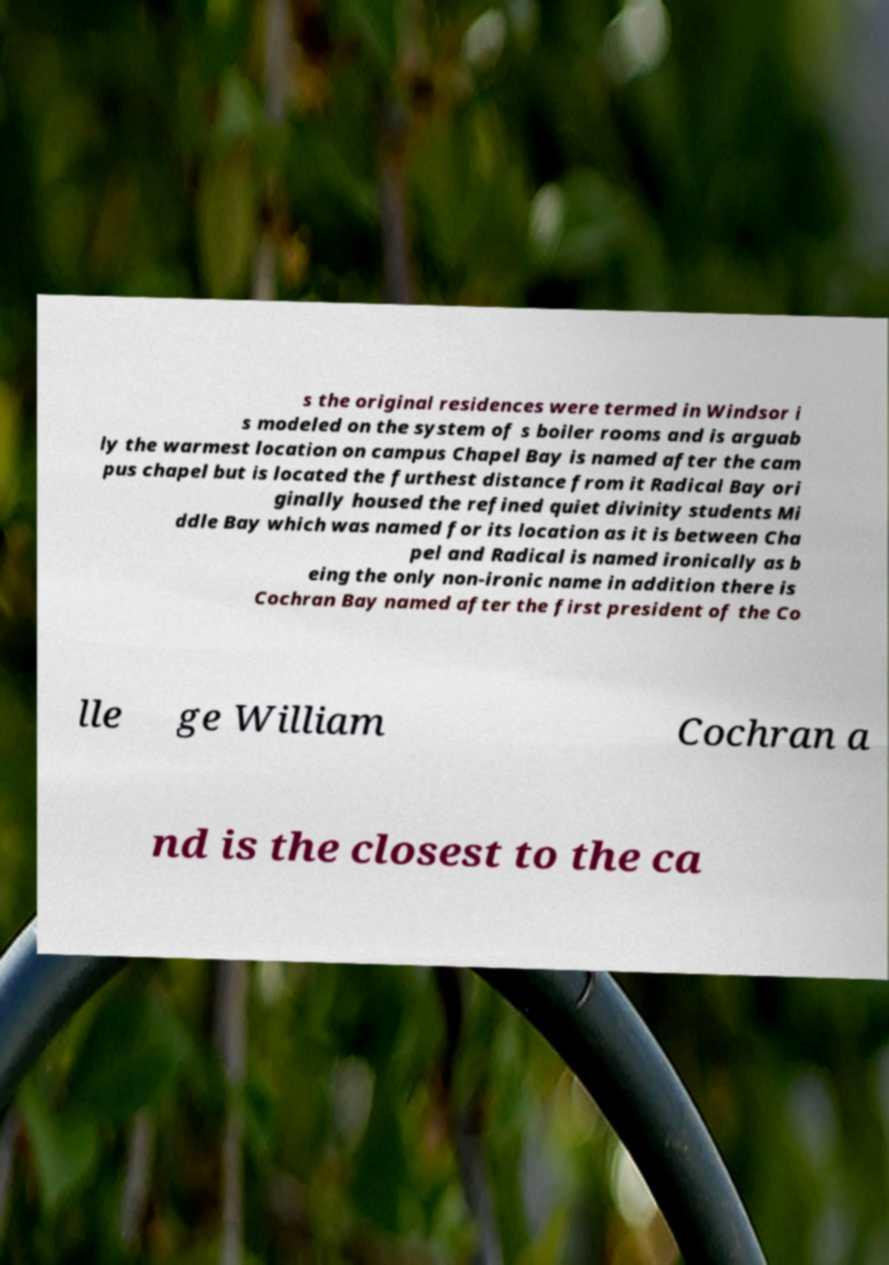There's text embedded in this image that I need extracted. Can you transcribe it verbatim? s the original residences were termed in Windsor i s modeled on the system of s boiler rooms and is arguab ly the warmest location on campus Chapel Bay is named after the cam pus chapel but is located the furthest distance from it Radical Bay ori ginally housed the refined quiet divinity students Mi ddle Bay which was named for its location as it is between Cha pel and Radical is named ironically as b eing the only non-ironic name in addition there is Cochran Bay named after the first president of the Co lle ge William Cochran a nd is the closest to the ca 